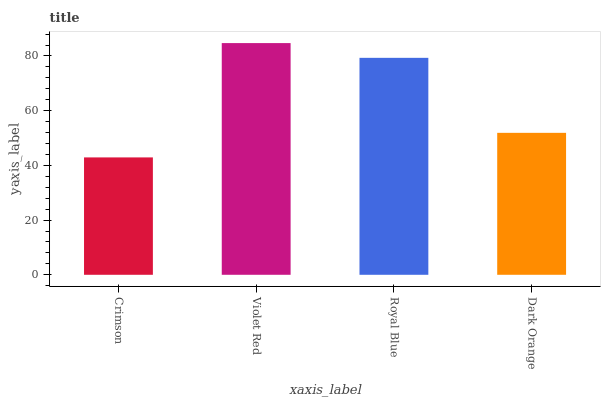Is Crimson the minimum?
Answer yes or no. Yes. Is Violet Red the maximum?
Answer yes or no. Yes. Is Royal Blue the minimum?
Answer yes or no. No. Is Royal Blue the maximum?
Answer yes or no. No. Is Violet Red greater than Royal Blue?
Answer yes or no. Yes. Is Royal Blue less than Violet Red?
Answer yes or no. Yes. Is Royal Blue greater than Violet Red?
Answer yes or no. No. Is Violet Red less than Royal Blue?
Answer yes or no. No. Is Royal Blue the high median?
Answer yes or no. Yes. Is Dark Orange the low median?
Answer yes or no. Yes. Is Dark Orange the high median?
Answer yes or no. No. Is Royal Blue the low median?
Answer yes or no. No. 